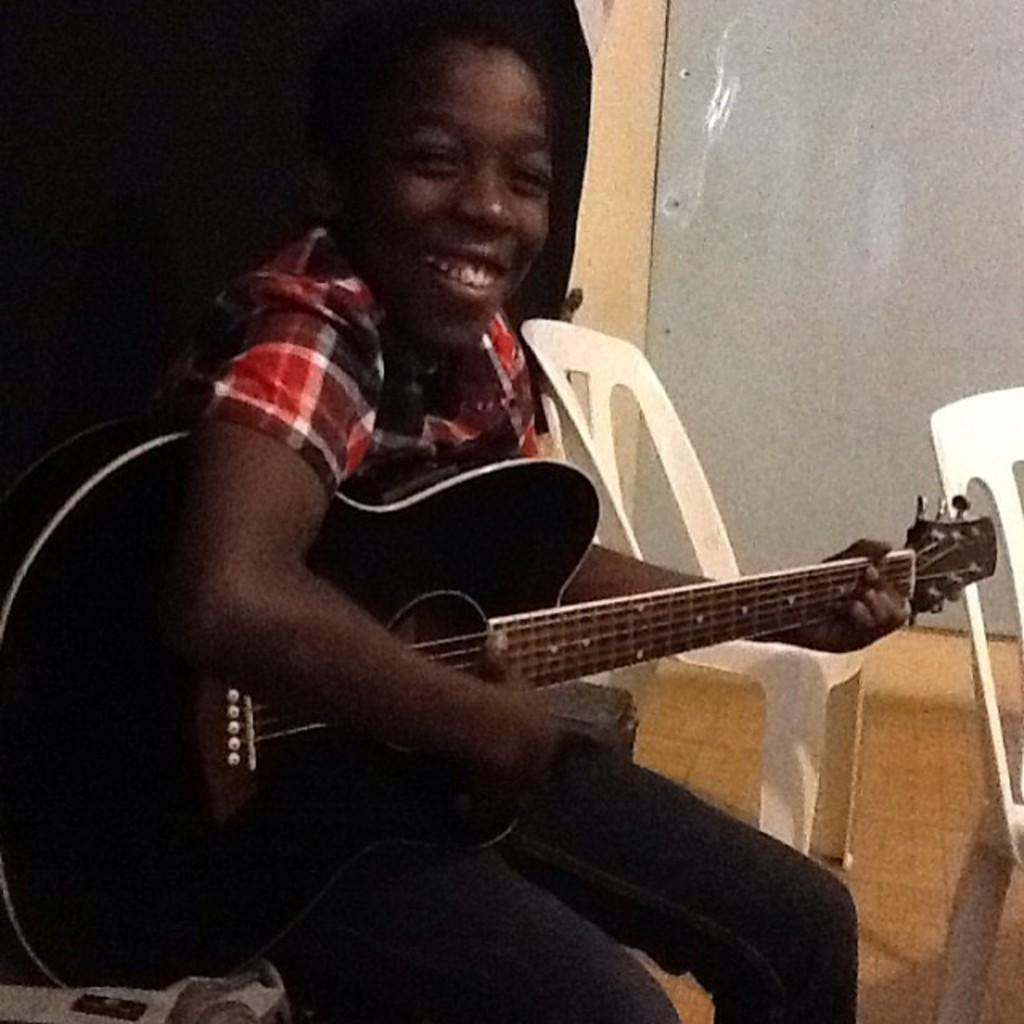Describe this image in one or two sentences. In this image we can see a person is playing a guitar and smiling. There are chairs on the floor. In the background we can see wall. 